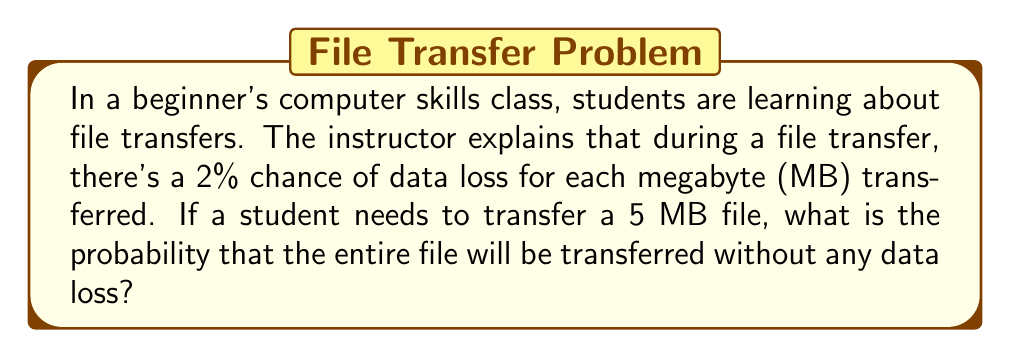Help me with this question. Let's approach this step-by-step:

1) First, we need to understand what the question is asking. We want to find the probability of successful transfer of all 5 MB without any data loss.

2) We're given that for each MB, there's a 2% chance of data loss. This means there's a 98% chance of successful transfer for each MB.

3) For the entire file to transfer successfully, each MB must transfer without data loss. This is an example of independent events.

4) When we want the probability of multiple independent events all occurring, we multiply the individual probabilities.

5) Let's express this mathematically:

   Let $p$ be the probability of successful transfer of the entire file.
   
   $p = (0.98)^5$

   This is because we're multiplying 0.98 (98% chance of success) five times (for 5 MB).

6) Now let's calculate:

   $p = (0.98)^5 = 0.9039208$

7) To convert to a percentage, we multiply by 100:

   $0.9039208 * 100 = 90.39208\%$

Therefore, the probability of transferring the entire 5 MB file without any data loss is approximately 90.39%.
Answer: $$90.39\%$$ or $$0.9039$$ (rounded to four decimal places) 